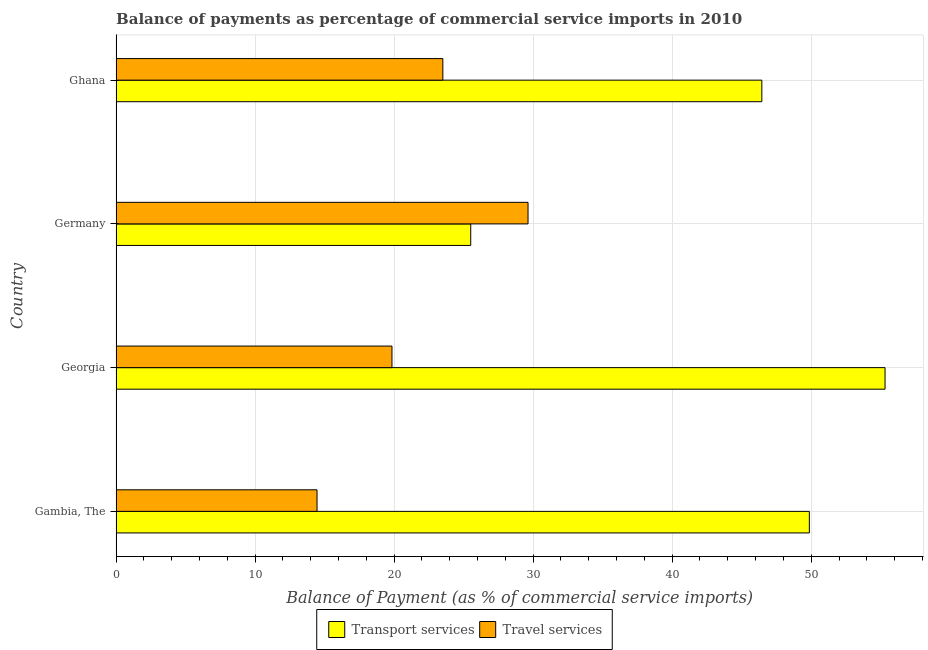Are the number of bars on each tick of the Y-axis equal?
Your response must be concise. Yes. What is the label of the 3rd group of bars from the top?
Provide a succinct answer. Georgia. In how many cases, is the number of bars for a given country not equal to the number of legend labels?
Your response must be concise. 0. What is the balance of payments of travel services in Ghana?
Provide a short and direct response. 23.5. Across all countries, what is the maximum balance of payments of travel services?
Keep it short and to the point. 29.63. Across all countries, what is the minimum balance of payments of transport services?
Offer a very short reply. 25.51. In which country was the balance of payments of travel services maximum?
Your response must be concise. Germany. In which country was the balance of payments of travel services minimum?
Provide a short and direct response. Gambia, The. What is the total balance of payments of transport services in the graph?
Your answer should be very brief. 177.14. What is the difference between the balance of payments of transport services in Germany and that in Ghana?
Your answer should be compact. -20.94. What is the difference between the balance of payments of travel services in Gambia, The and the balance of payments of transport services in Georgia?
Offer a very short reply. -40.86. What is the average balance of payments of transport services per country?
Keep it short and to the point. 44.28. What is the difference between the balance of payments of transport services and balance of payments of travel services in Ghana?
Provide a succinct answer. 22.95. In how many countries, is the balance of payments of travel services greater than 16 %?
Offer a terse response. 3. What is the ratio of the balance of payments of transport services in Gambia, The to that in Ghana?
Provide a short and direct response. 1.07. What is the difference between the highest and the second highest balance of payments of transport services?
Provide a short and direct response. 5.45. What is the difference between the highest and the lowest balance of payments of transport services?
Offer a terse response. 29.8. In how many countries, is the balance of payments of transport services greater than the average balance of payments of transport services taken over all countries?
Provide a short and direct response. 3. Is the sum of the balance of payments of transport services in Georgia and Ghana greater than the maximum balance of payments of travel services across all countries?
Offer a terse response. Yes. What does the 2nd bar from the top in Ghana represents?
Ensure brevity in your answer.  Transport services. What does the 2nd bar from the bottom in Gambia, The represents?
Your response must be concise. Travel services. How many bars are there?
Offer a terse response. 8. Are all the bars in the graph horizontal?
Provide a succinct answer. Yes. What is the difference between two consecutive major ticks on the X-axis?
Your answer should be very brief. 10. Does the graph contain any zero values?
Your answer should be very brief. No. Does the graph contain grids?
Provide a short and direct response. Yes. Where does the legend appear in the graph?
Ensure brevity in your answer.  Bottom center. How many legend labels are there?
Provide a succinct answer. 2. How are the legend labels stacked?
Keep it short and to the point. Horizontal. What is the title of the graph?
Provide a short and direct response. Balance of payments as percentage of commercial service imports in 2010. Does "Imports" appear as one of the legend labels in the graph?
Your answer should be compact. No. What is the label or title of the X-axis?
Give a very brief answer. Balance of Payment (as % of commercial service imports). What is the label or title of the Y-axis?
Your response must be concise. Country. What is the Balance of Payment (as % of commercial service imports) of Transport services in Gambia, The?
Offer a terse response. 49.87. What is the Balance of Payment (as % of commercial service imports) of Travel services in Gambia, The?
Offer a very short reply. 14.45. What is the Balance of Payment (as % of commercial service imports) in Transport services in Georgia?
Your answer should be very brief. 55.31. What is the Balance of Payment (as % of commercial service imports) of Travel services in Georgia?
Give a very brief answer. 19.84. What is the Balance of Payment (as % of commercial service imports) of Transport services in Germany?
Provide a short and direct response. 25.51. What is the Balance of Payment (as % of commercial service imports) of Travel services in Germany?
Your answer should be compact. 29.63. What is the Balance of Payment (as % of commercial service imports) in Transport services in Ghana?
Offer a terse response. 46.45. What is the Balance of Payment (as % of commercial service imports) of Travel services in Ghana?
Provide a succinct answer. 23.5. Across all countries, what is the maximum Balance of Payment (as % of commercial service imports) of Transport services?
Give a very brief answer. 55.31. Across all countries, what is the maximum Balance of Payment (as % of commercial service imports) in Travel services?
Give a very brief answer. 29.63. Across all countries, what is the minimum Balance of Payment (as % of commercial service imports) of Transport services?
Give a very brief answer. 25.51. Across all countries, what is the minimum Balance of Payment (as % of commercial service imports) in Travel services?
Give a very brief answer. 14.45. What is the total Balance of Payment (as % of commercial service imports) of Transport services in the graph?
Your answer should be very brief. 177.14. What is the total Balance of Payment (as % of commercial service imports) in Travel services in the graph?
Give a very brief answer. 87.43. What is the difference between the Balance of Payment (as % of commercial service imports) in Transport services in Gambia, The and that in Georgia?
Provide a short and direct response. -5.45. What is the difference between the Balance of Payment (as % of commercial service imports) of Travel services in Gambia, The and that in Georgia?
Provide a short and direct response. -5.39. What is the difference between the Balance of Payment (as % of commercial service imports) of Transport services in Gambia, The and that in Germany?
Provide a succinct answer. 24.36. What is the difference between the Balance of Payment (as % of commercial service imports) of Travel services in Gambia, The and that in Germany?
Offer a very short reply. -15.18. What is the difference between the Balance of Payment (as % of commercial service imports) in Transport services in Gambia, The and that in Ghana?
Make the answer very short. 3.42. What is the difference between the Balance of Payment (as % of commercial service imports) in Travel services in Gambia, The and that in Ghana?
Your answer should be compact. -9.05. What is the difference between the Balance of Payment (as % of commercial service imports) of Transport services in Georgia and that in Germany?
Provide a succinct answer. 29.8. What is the difference between the Balance of Payment (as % of commercial service imports) of Travel services in Georgia and that in Germany?
Your response must be concise. -9.79. What is the difference between the Balance of Payment (as % of commercial service imports) of Transport services in Georgia and that in Ghana?
Your response must be concise. 8.86. What is the difference between the Balance of Payment (as % of commercial service imports) in Travel services in Georgia and that in Ghana?
Your answer should be compact. -3.66. What is the difference between the Balance of Payment (as % of commercial service imports) in Transport services in Germany and that in Ghana?
Offer a very short reply. -20.94. What is the difference between the Balance of Payment (as % of commercial service imports) in Travel services in Germany and that in Ghana?
Offer a very short reply. 6.13. What is the difference between the Balance of Payment (as % of commercial service imports) in Transport services in Gambia, The and the Balance of Payment (as % of commercial service imports) in Travel services in Georgia?
Provide a succinct answer. 30.02. What is the difference between the Balance of Payment (as % of commercial service imports) in Transport services in Gambia, The and the Balance of Payment (as % of commercial service imports) in Travel services in Germany?
Your answer should be very brief. 20.24. What is the difference between the Balance of Payment (as % of commercial service imports) in Transport services in Gambia, The and the Balance of Payment (as % of commercial service imports) in Travel services in Ghana?
Keep it short and to the point. 26.36. What is the difference between the Balance of Payment (as % of commercial service imports) in Transport services in Georgia and the Balance of Payment (as % of commercial service imports) in Travel services in Germany?
Your response must be concise. 25.68. What is the difference between the Balance of Payment (as % of commercial service imports) of Transport services in Georgia and the Balance of Payment (as % of commercial service imports) of Travel services in Ghana?
Ensure brevity in your answer.  31.81. What is the difference between the Balance of Payment (as % of commercial service imports) in Transport services in Germany and the Balance of Payment (as % of commercial service imports) in Travel services in Ghana?
Your answer should be compact. 2.01. What is the average Balance of Payment (as % of commercial service imports) of Transport services per country?
Your answer should be compact. 44.28. What is the average Balance of Payment (as % of commercial service imports) of Travel services per country?
Your answer should be compact. 21.86. What is the difference between the Balance of Payment (as % of commercial service imports) in Transport services and Balance of Payment (as % of commercial service imports) in Travel services in Gambia, The?
Your answer should be very brief. 35.41. What is the difference between the Balance of Payment (as % of commercial service imports) of Transport services and Balance of Payment (as % of commercial service imports) of Travel services in Georgia?
Your answer should be compact. 35.47. What is the difference between the Balance of Payment (as % of commercial service imports) of Transport services and Balance of Payment (as % of commercial service imports) of Travel services in Germany?
Your answer should be very brief. -4.12. What is the difference between the Balance of Payment (as % of commercial service imports) in Transport services and Balance of Payment (as % of commercial service imports) in Travel services in Ghana?
Provide a short and direct response. 22.95. What is the ratio of the Balance of Payment (as % of commercial service imports) of Transport services in Gambia, The to that in Georgia?
Keep it short and to the point. 0.9. What is the ratio of the Balance of Payment (as % of commercial service imports) in Travel services in Gambia, The to that in Georgia?
Offer a terse response. 0.73. What is the ratio of the Balance of Payment (as % of commercial service imports) in Transport services in Gambia, The to that in Germany?
Keep it short and to the point. 1.95. What is the ratio of the Balance of Payment (as % of commercial service imports) of Travel services in Gambia, The to that in Germany?
Your answer should be very brief. 0.49. What is the ratio of the Balance of Payment (as % of commercial service imports) in Transport services in Gambia, The to that in Ghana?
Ensure brevity in your answer.  1.07. What is the ratio of the Balance of Payment (as % of commercial service imports) in Travel services in Gambia, The to that in Ghana?
Provide a succinct answer. 0.61. What is the ratio of the Balance of Payment (as % of commercial service imports) in Transport services in Georgia to that in Germany?
Provide a short and direct response. 2.17. What is the ratio of the Balance of Payment (as % of commercial service imports) of Travel services in Georgia to that in Germany?
Your response must be concise. 0.67. What is the ratio of the Balance of Payment (as % of commercial service imports) in Transport services in Georgia to that in Ghana?
Make the answer very short. 1.19. What is the ratio of the Balance of Payment (as % of commercial service imports) of Travel services in Georgia to that in Ghana?
Your answer should be compact. 0.84. What is the ratio of the Balance of Payment (as % of commercial service imports) in Transport services in Germany to that in Ghana?
Make the answer very short. 0.55. What is the ratio of the Balance of Payment (as % of commercial service imports) in Travel services in Germany to that in Ghana?
Make the answer very short. 1.26. What is the difference between the highest and the second highest Balance of Payment (as % of commercial service imports) in Transport services?
Your answer should be very brief. 5.45. What is the difference between the highest and the second highest Balance of Payment (as % of commercial service imports) of Travel services?
Offer a terse response. 6.13. What is the difference between the highest and the lowest Balance of Payment (as % of commercial service imports) of Transport services?
Your response must be concise. 29.8. What is the difference between the highest and the lowest Balance of Payment (as % of commercial service imports) of Travel services?
Ensure brevity in your answer.  15.18. 